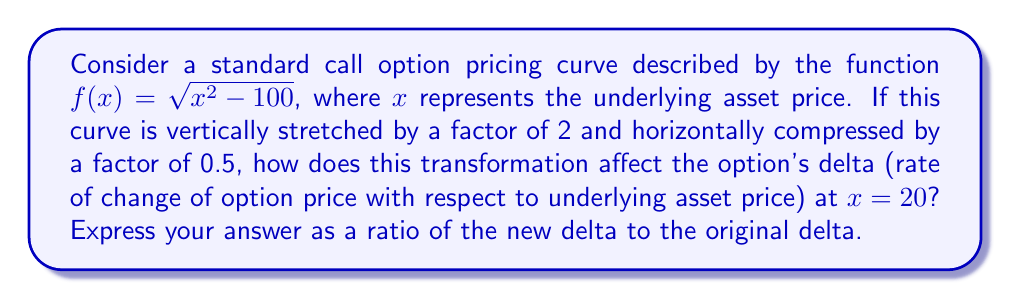Show me your answer to this math problem. Let's approach this step-by-step:

1) The original function is $f(x) = \sqrt{x^2 - 100}$

2) After the transformation, the new function $g(x)$ is:
   $g(x) = 2f(2x) = 2\sqrt{(2x)^2 - 100} = 2\sqrt{4x^2 - 100}$

3) To find the delta, we need to differentiate both functions:

   For $f(x)$:
   $$f'(x) = \frac{2x}{2\sqrt{x^2 - 100}} = \frac{x}{\sqrt{x^2 - 100}}$$

   For $g(x)$:
   $$g'(x) = 2 \cdot \frac{8x}{2\sqrt{4x^2 - 100}} = \frac{8x}{\sqrt{4x^2 - 100}}$$

4) Now, we evaluate these at $x = 20$:

   $f'(20) = \frac{20}{\sqrt{20^2 - 100}} = \frac{20}{\sqrt{300}} = \frac{20\sqrt{3}}{30}$

   $g'(20) = \frac{8(20)}{\sqrt{4(20)^2 - 100}} = \frac{160}{\sqrt{1500}} = \frac{160\sqrt{3}}{60}$

5) The ratio of the new delta to the original delta is:

   $$\frac{g'(20)}{f'(20)} = \frac{160\sqrt{3}/60}{20\sqrt{3}/30} = \frac{160 \cdot 30}{20 \cdot 60} = 4$$
Answer: 4 